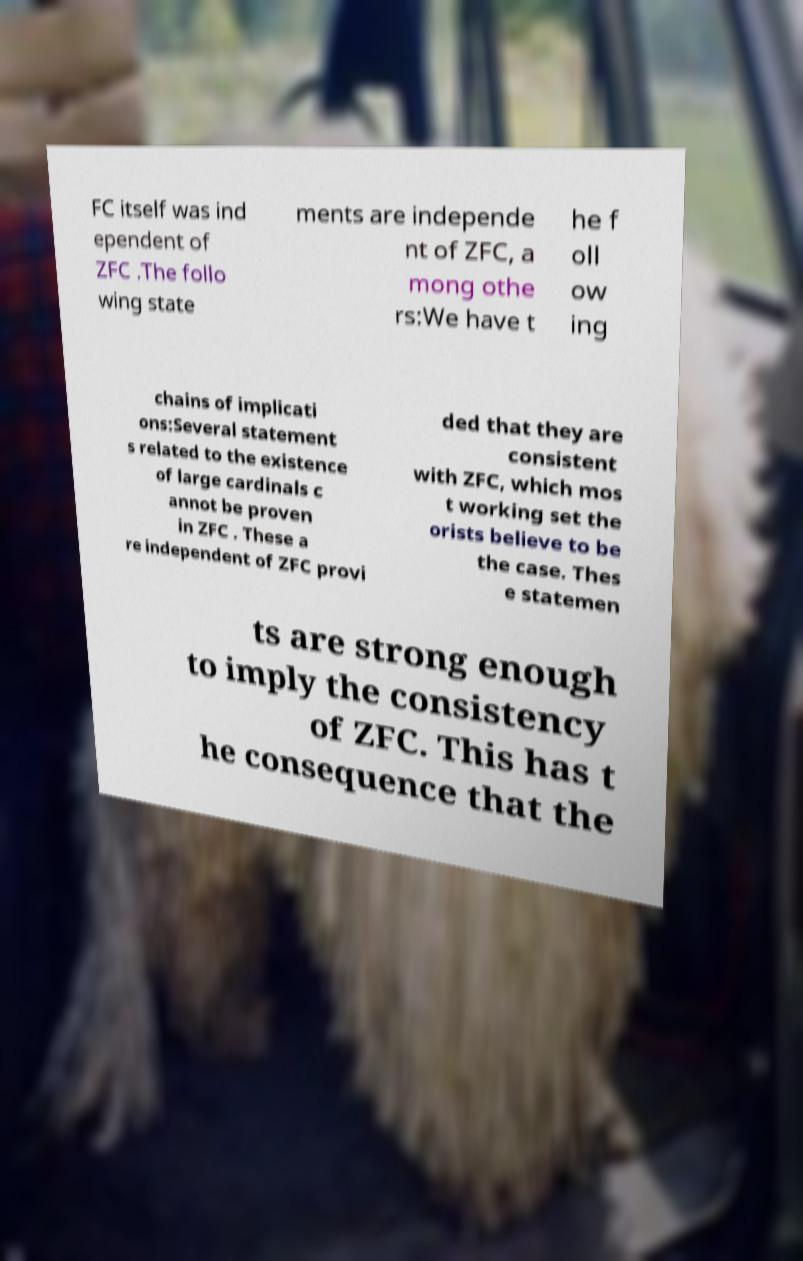Please identify and transcribe the text found in this image. FC itself was ind ependent of ZFC .The follo wing state ments are independe nt of ZFC, a mong othe rs:We have t he f oll ow ing chains of implicati ons:Several statement s related to the existence of large cardinals c annot be proven in ZFC . These a re independent of ZFC provi ded that they are consistent with ZFC, which mos t working set the orists believe to be the case. Thes e statemen ts are strong enough to imply the consistency of ZFC. This has t he consequence that the 